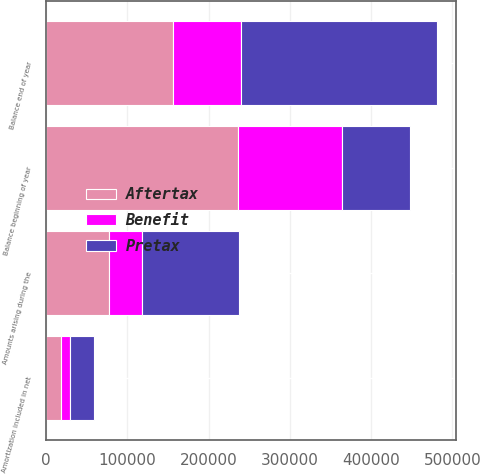<chart> <loc_0><loc_0><loc_500><loc_500><stacked_bar_chart><ecel><fcel>Balance beginning of year<fcel>Amounts arising during the<fcel>Amortization included in net<fcel>Balance end of year<nl><fcel>Pretax<fcel>84122<fcel>118666<fcel>29194<fcel>240345<nl><fcel>Benefit<fcel>127292<fcel>41532<fcel>10218<fcel>84122<nl><fcel>Aftertax<fcel>236399<fcel>77134<fcel>18976<fcel>156223<nl></chart> 